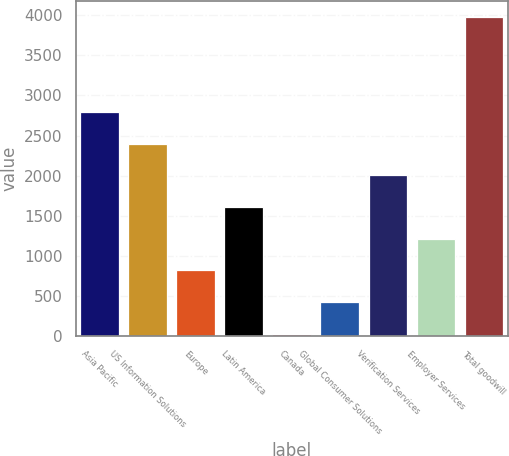Convert chart to OTSL. <chart><loc_0><loc_0><loc_500><loc_500><bar_chart><fcel>Asia Pacific<fcel>US Information Solutions<fcel>Europe<fcel>Latin America<fcel>Canada<fcel>Global Consumer Solutions<fcel>Verification Services<fcel>Employer Services<fcel>Total goodwill<nl><fcel>2791.94<fcel>2397.82<fcel>821.34<fcel>1609.58<fcel>33.1<fcel>427.22<fcel>2003.7<fcel>1215.46<fcel>3974.3<nl></chart> 